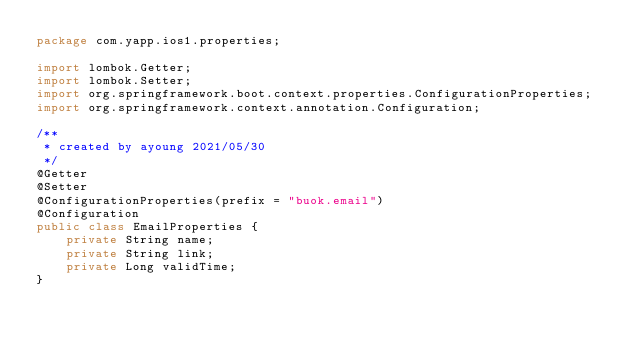Convert code to text. <code><loc_0><loc_0><loc_500><loc_500><_Java_>package com.yapp.ios1.properties;

import lombok.Getter;
import lombok.Setter;
import org.springframework.boot.context.properties.ConfigurationProperties;
import org.springframework.context.annotation.Configuration;

/**
 * created by ayoung 2021/05/30
 */
@Getter
@Setter
@ConfigurationProperties(prefix = "buok.email")
@Configuration
public class EmailProperties {
    private String name;
    private String link;
    private Long validTime;
}
</code> 